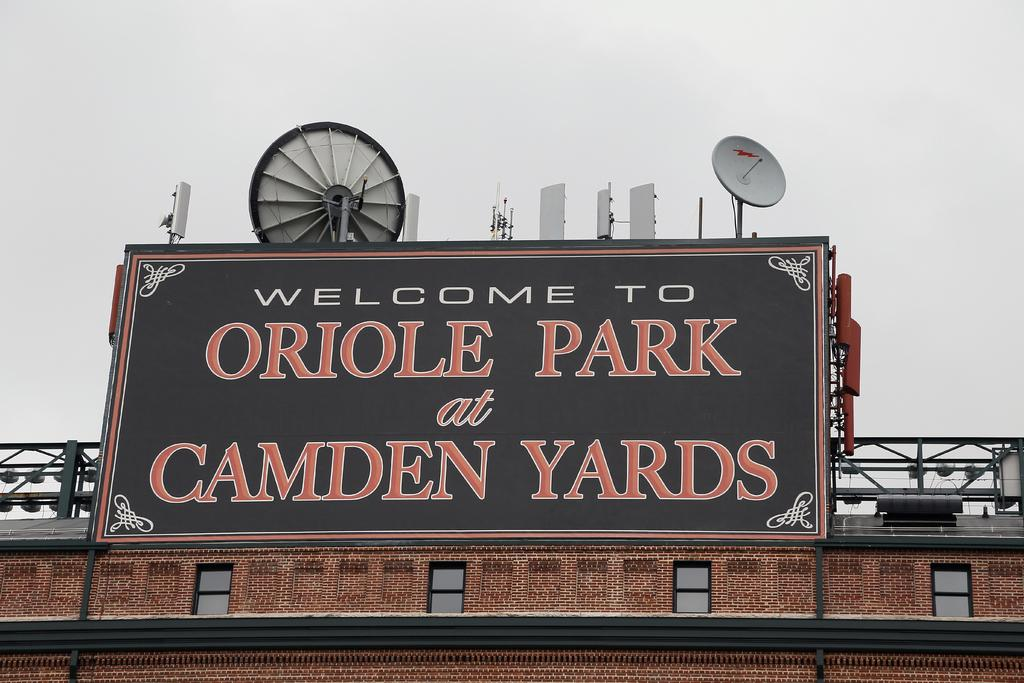<image>
Write a terse but informative summary of the picture. A large billboard on a brick building says Welcome To Oriole Park at Camden Yards. 